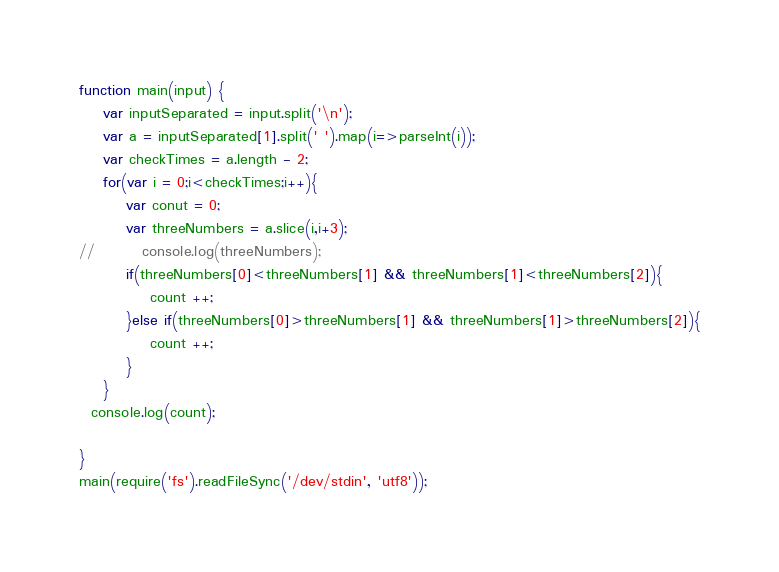<code> <loc_0><loc_0><loc_500><loc_500><_JavaScript_>function main(input) {
	var inputSeparated = input.split('\n');
  	var a = inputSeparated[1].split(' ').map(i=>parseInt(i));
  	var checkTimes = a.length - 2;
  	for(var i = 0;i<checkTimes;i++){
      	var conut = 0;
    	var threeNumbers = a.slice(i,i+3);
//        console.log(threeNumbers);
      	if(threeNumbers[0]<threeNumbers[1] && threeNumbers[1]<threeNumbers[2]){
			count ++; 
        }else if(threeNumbers[0]>threeNumbers[1] && threeNumbers[1]>threeNumbers[2]){
         	count ++; 
        }
    }
  console.log(count);

}
main(require('fs').readFileSync('/dev/stdin', 'utf8'));</code> 